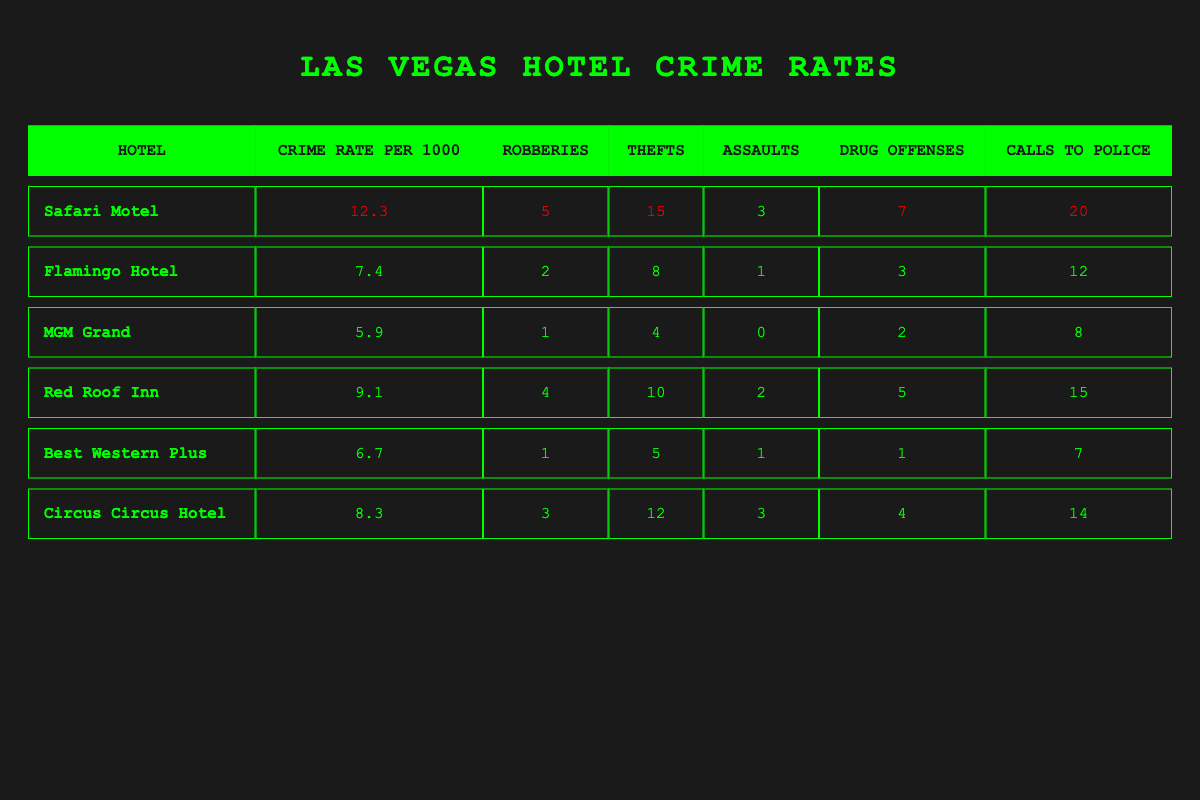What is the crime rate per 1000 at the Safari Motel? The table clearly shows the crime rate per 1000 for the Safari Motel as 12.3.
Answer: 12.3 Which hotel has the highest number of thefts? The table indicates that the Safari Motel has the highest number of thefts at 15, compared to other hotels listed.
Answer: Safari Motel How many total calls to police were made for all hotels combined? Summing up the calls to police for each hotel: 20 (Safari Motel) + 12 (Flamingo Hotel) + 8 (MGM Grand) + 15 (Red Roof Inn) + 7 (Best Western Plus) + 14 (Circus Circus Hotel) = 76.
Answer: 76 Is the crime rate at the MGM Grand lower than that of the Red Roof Inn? The crime rate at the MGM Grand is 5.9, and the Red Roof Inn is 9.1. Since 5.9 < 9.1, the statement is true.
Answer: Yes What is the average number of drug offenses across all hotels? Adding the drug offenses for all hotels: 7 (Safari Motel) + 3 (Flamingo Hotel) + 2 (MGM Grand) + 5 (Red Roof Inn) + 1 (Best Western Plus) + 4 (Circus Circus Hotel) = 22. Dividing by the total number of hotels (6), the average is 22/6 = 3.67.
Answer: 3.67 Which hotel has more total crimes, Safari Motel or Red Roof Inn? Calculate total crimes: Safari Motel has 5 (robberies) + 15 (thefts) + 3 (assaults) + 7 (drug offenses) = 30. Red Roof Inn has 4 + 10 + 2 + 5 = 21. Since 30 > 21, Safari Motel has more total crimes.
Answer: Safari Motel What is the difference in calls to police between the highest and lowest hotel? The highest calls to police is 20 (Safari Motel) and the lowest is 7 (Best Western Plus). The difference is 20 - 7 = 13.
Answer: 13 Are there more drug offenses at Flamingo Hotel than MGM Grand? The Flamingo Hotel has 3 drug offenses and the MGM Grand has 2. Comparing these values shows that 3 > 2, so the answer is yes.
Answer: Yes Which hotel has the least number of robberies? The MGM Grand has the least number of robberies with only 1 recorded incident.
Answer: MGM Grand What percentage of the total crimes at the Safari Motel are due to theft? Total crimes at Safari Motel are 30 (as calculated earlier). The number of thefts is 15. Therefore, the percentage is (15/30) * 100 = 50%.
Answer: 50% 